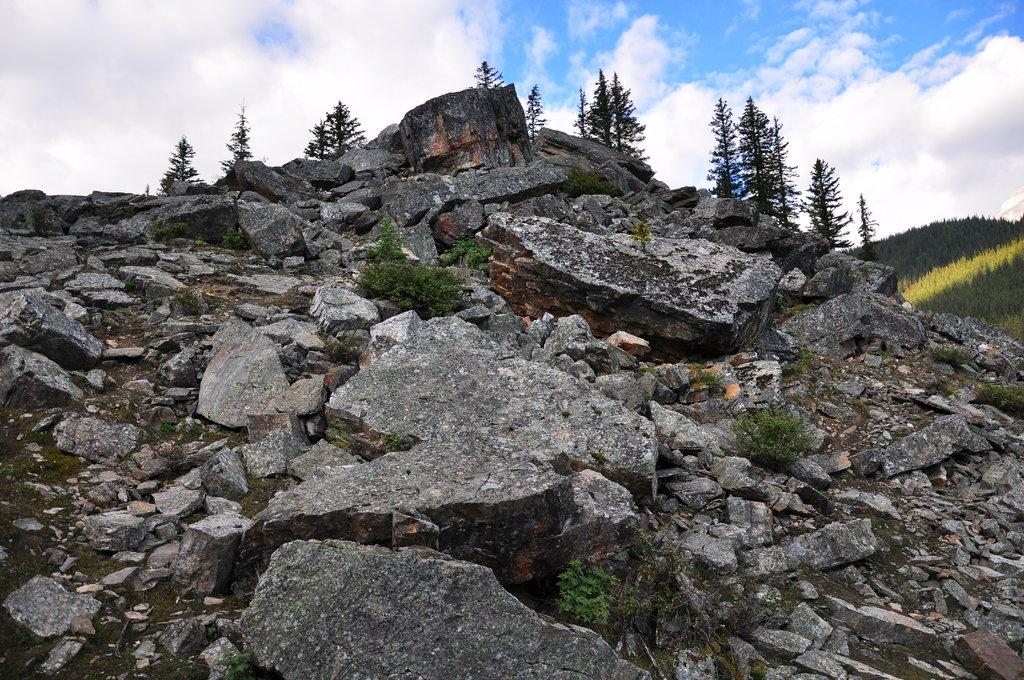What type of natural elements can be seen in the image? There are rocks and plants visible in the image. How are the rocks arranged in the image? The rocks are scattered throughout the image, with plants growing between them. What can be seen in the right corner of the image? There are greenery mountains in the right corner of the image. What type of bun is being used to hold the meat in the image? There is no bun or meat present in the image; it features rocks, plants, and mountains. 